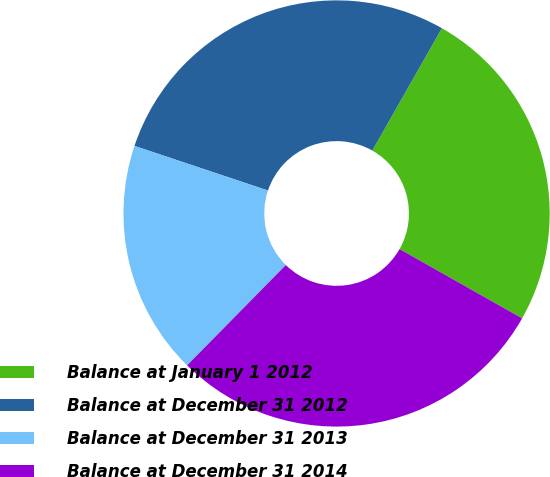Convert chart. <chart><loc_0><loc_0><loc_500><loc_500><pie_chart><fcel>Balance at January 1 2012<fcel>Balance at December 31 2012<fcel>Balance at December 31 2013<fcel>Balance at December 31 2014<nl><fcel>24.96%<fcel>28.09%<fcel>17.76%<fcel>29.18%<nl></chart> 